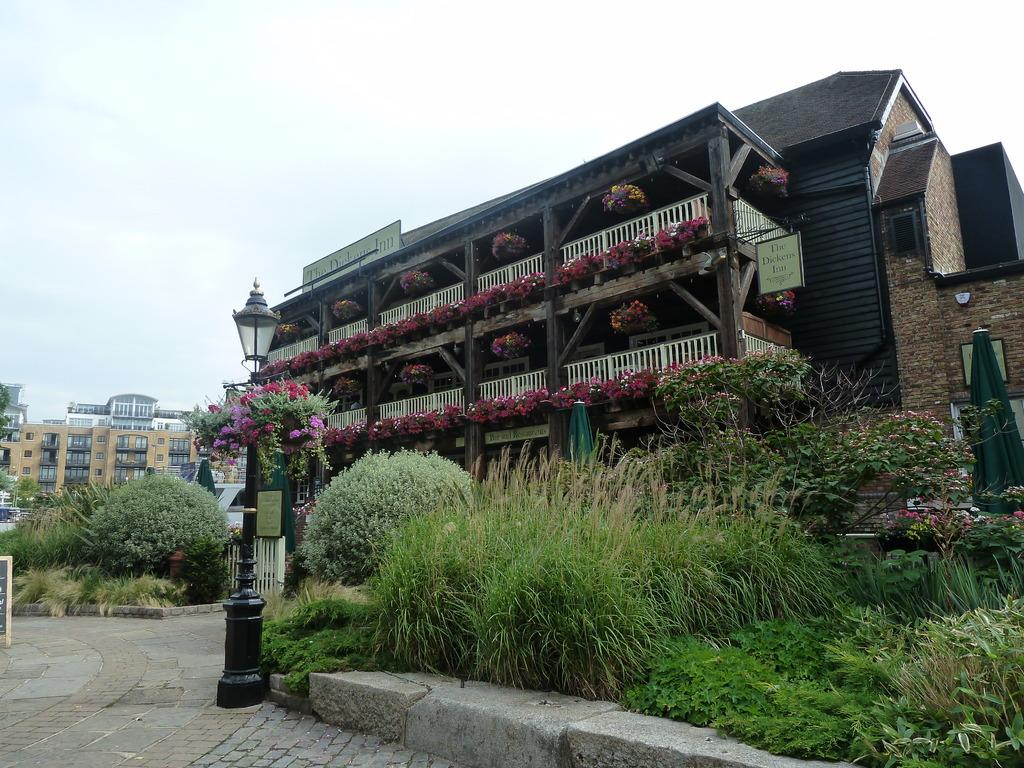What type of house is in the image? There is a wooden house in the image. What feature of the house is mentioned in the facts? The house has a white color balcony. What other elements can be seen in the image? There are flowers and plants visible in the image. What can be observed in the background of the image? There are many buildings visible in the background. Can you tell me how many girls are shaking hands with the horse in the image? There are no girls or horses present in the image. 